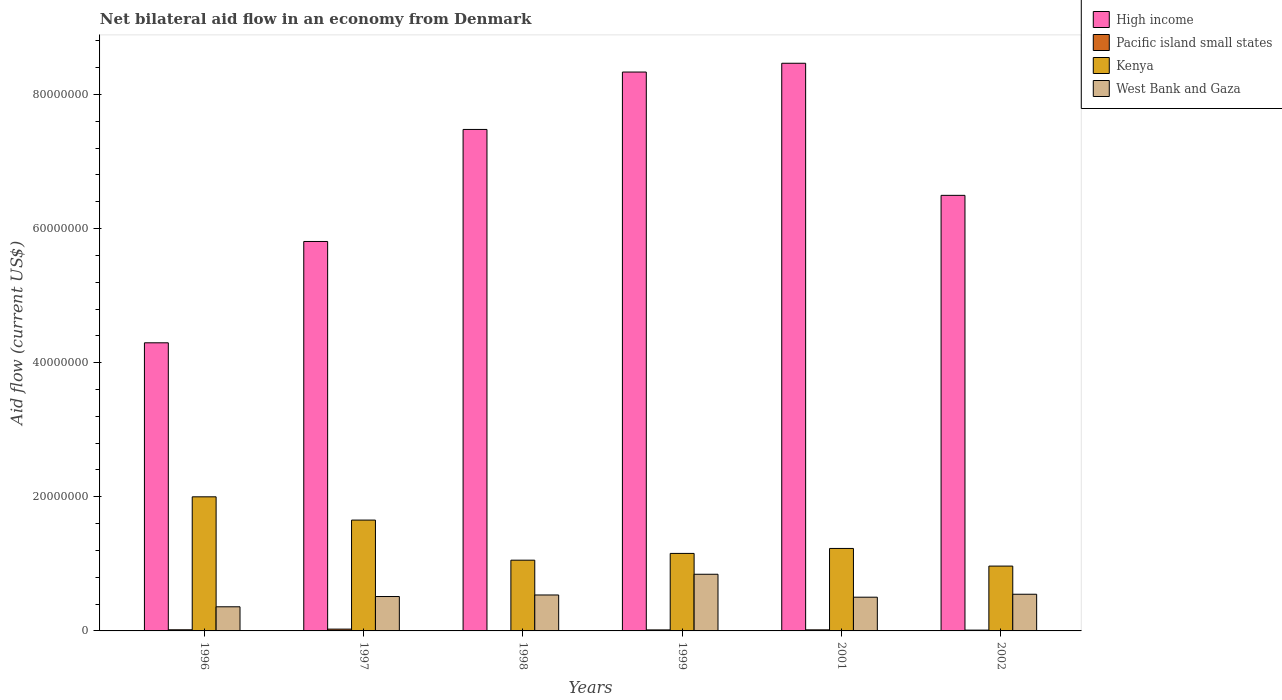Are the number of bars per tick equal to the number of legend labels?
Ensure brevity in your answer.  No. How many bars are there on the 6th tick from the left?
Provide a succinct answer. 4. What is the label of the 3rd group of bars from the left?
Keep it short and to the point. 1998. In how many cases, is the number of bars for a given year not equal to the number of legend labels?
Your answer should be compact. 1. What is the net bilateral aid flow in West Bank and Gaza in 1997?
Offer a terse response. 5.13e+06. Across all years, what is the maximum net bilateral aid flow in High income?
Give a very brief answer. 8.47e+07. In which year was the net bilateral aid flow in West Bank and Gaza maximum?
Offer a very short reply. 1999. What is the total net bilateral aid flow in West Bank and Gaza in the graph?
Offer a terse response. 3.30e+07. What is the difference between the net bilateral aid flow in High income in 1998 and that in 1999?
Give a very brief answer. -8.56e+06. What is the difference between the net bilateral aid flow in Pacific island small states in 1999 and the net bilateral aid flow in West Bank and Gaza in 1996?
Your answer should be very brief. -3.45e+06. What is the average net bilateral aid flow in Kenya per year?
Your answer should be very brief. 1.34e+07. In the year 1996, what is the difference between the net bilateral aid flow in Pacific island small states and net bilateral aid flow in High income?
Your answer should be very brief. -4.28e+07. In how many years, is the net bilateral aid flow in High income greater than 56000000 US$?
Your answer should be very brief. 5. What is the difference between the highest and the second highest net bilateral aid flow in High income?
Your answer should be compact. 1.31e+06. What is the difference between the highest and the lowest net bilateral aid flow in High income?
Give a very brief answer. 4.17e+07. In how many years, is the net bilateral aid flow in High income greater than the average net bilateral aid flow in High income taken over all years?
Provide a succinct answer. 3. Is it the case that in every year, the sum of the net bilateral aid flow in High income and net bilateral aid flow in Kenya is greater than the sum of net bilateral aid flow in Pacific island small states and net bilateral aid flow in West Bank and Gaza?
Offer a very short reply. No. Are the values on the major ticks of Y-axis written in scientific E-notation?
Offer a very short reply. No. Does the graph contain grids?
Provide a short and direct response. No. Where does the legend appear in the graph?
Your answer should be very brief. Top right. What is the title of the graph?
Make the answer very short. Net bilateral aid flow in an economy from Denmark. Does "Mauritania" appear as one of the legend labels in the graph?
Give a very brief answer. No. What is the label or title of the Y-axis?
Your response must be concise. Aid flow (current US$). What is the Aid flow (current US$) of High income in 1996?
Your answer should be compact. 4.30e+07. What is the Aid flow (current US$) of Kenya in 1996?
Provide a succinct answer. 2.00e+07. What is the Aid flow (current US$) in West Bank and Gaza in 1996?
Your response must be concise. 3.60e+06. What is the Aid flow (current US$) in High income in 1997?
Offer a very short reply. 5.81e+07. What is the Aid flow (current US$) of Kenya in 1997?
Your answer should be very brief. 1.65e+07. What is the Aid flow (current US$) in West Bank and Gaza in 1997?
Offer a terse response. 5.13e+06. What is the Aid flow (current US$) of High income in 1998?
Offer a very short reply. 7.48e+07. What is the Aid flow (current US$) in Pacific island small states in 1998?
Your answer should be very brief. 0. What is the Aid flow (current US$) of Kenya in 1998?
Your answer should be compact. 1.06e+07. What is the Aid flow (current US$) in West Bank and Gaza in 1998?
Keep it short and to the point. 5.36e+06. What is the Aid flow (current US$) in High income in 1999?
Provide a succinct answer. 8.34e+07. What is the Aid flow (current US$) of Kenya in 1999?
Give a very brief answer. 1.16e+07. What is the Aid flow (current US$) in West Bank and Gaza in 1999?
Offer a terse response. 8.45e+06. What is the Aid flow (current US$) of High income in 2001?
Provide a short and direct response. 8.47e+07. What is the Aid flow (current US$) in Kenya in 2001?
Keep it short and to the point. 1.23e+07. What is the Aid flow (current US$) of West Bank and Gaza in 2001?
Provide a short and direct response. 5.03e+06. What is the Aid flow (current US$) of High income in 2002?
Ensure brevity in your answer.  6.50e+07. What is the Aid flow (current US$) of Kenya in 2002?
Keep it short and to the point. 9.67e+06. What is the Aid flow (current US$) of West Bank and Gaza in 2002?
Provide a short and direct response. 5.47e+06. Across all years, what is the maximum Aid flow (current US$) of High income?
Ensure brevity in your answer.  8.47e+07. Across all years, what is the maximum Aid flow (current US$) in Pacific island small states?
Ensure brevity in your answer.  2.70e+05. Across all years, what is the maximum Aid flow (current US$) of West Bank and Gaza?
Your answer should be very brief. 8.45e+06. Across all years, what is the minimum Aid flow (current US$) in High income?
Ensure brevity in your answer.  4.30e+07. Across all years, what is the minimum Aid flow (current US$) in Kenya?
Give a very brief answer. 9.67e+06. Across all years, what is the minimum Aid flow (current US$) in West Bank and Gaza?
Provide a succinct answer. 3.60e+06. What is the total Aid flow (current US$) in High income in the graph?
Your answer should be compact. 4.09e+08. What is the total Aid flow (current US$) of Pacific island small states in the graph?
Make the answer very short. 8.70e+05. What is the total Aid flow (current US$) in Kenya in the graph?
Your response must be concise. 8.06e+07. What is the total Aid flow (current US$) in West Bank and Gaza in the graph?
Your response must be concise. 3.30e+07. What is the difference between the Aid flow (current US$) of High income in 1996 and that in 1997?
Offer a terse response. -1.51e+07. What is the difference between the Aid flow (current US$) of Kenya in 1996 and that in 1997?
Offer a very short reply. 3.47e+06. What is the difference between the Aid flow (current US$) of West Bank and Gaza in 1996 and that in 1997?
Give a very brief answer. -1.53e+06. What is the difference between the Aid flow (current US$) of High income in 1996 and that in 1998?
Your response must be concise. -3.18e+07. What is the difference between the Aid flow (current US$) in Kenya in 1996 and that in 1998?
Provide a short and direct response. 9.45e+06. What is the difference between the Aid flow (current US$) of West Bank and Gaza in 1996 and that in 1998?
Your answer should be compact. -1.76e+06. What is the difference between the Aid flow (current US$) in High income in 1996 and that in 1999?
Offer a very short reply. -4.04e+07. What is the difference between the Aid flow (current US$) of Kenya in 1996 and that in 1999?
Keep it short and to the point. 8.44e+06. What is the difference between the Aid flow (current US$) in West Bank and Gaza in 1996 and that in 1999?
Give a very brief answer. -4.85e+06. What is the difference between the Aid flow (current US$) of High income in 1996 and that in 2001?
Your response must be concise. -4.17e+07. What is the difference between the Aid flow (current US$) in Kenya in 1996 and that in 2001?
Make the answer very short. 7.70e+06. What is the difference between the Aid flow (current US$) of West Bank and Gaza in 1996 and that in 2001?
Make the answer very short. -1.43e+06. What is the difference between the Aid flow (current US$) of High income in 1996 and that in 2002?
Provide a succinct answer. -2.20e+07. What is the difference between the Aid flow (current US$) of Kenya in 1996 and that in 2002?
Your response must be concise. 1.03e+07. What is the difference between the Aid flow (current US$) of West Bank and Gaza in 1996 and that in 2002?
Your response must be concise. -1.87e+06. What is the difference between the Aid flow (current US$) in High income in 1997 and that in 1998?
Ensure brevity in your answer.  -1.67e+07. What is the difference between the Aid flow (current US$) in Kenya in 1997 and that in 1998?
Keep it short and to the point. 5.98e+06. What is the difference between the Aid flow (current US$) of West Bank and Gaza in 1997 and that in 1998?
Provide a short and direct response. -2.30e+05. What is the difference between the Aid flow (current US$) in High income in 1997 and that in 1999?
Make the answer very short. -2.53e+07. What is the difference between the Aid flow (current US$) in Kenya in 1997 and that in 1999?
Ensure brevity in your answer.  4.97e+06. What is the difference between the Aid flow (current US$) of West Bank and Gaza in 1997 and that in 1999?
Offer a terse response. -3.32e+06. What is the difference between the Aid flow (current US$) of High income in 1997 and that in 2001?
Your answer should be very brief. -2.66e+07. What is the difference between the Aid flow (current US$) in Kenya in 1997 and that in 2001?
Offer a very short reply. 4.23e+06. What is the difference between the Aid flow (current US$) in High income in 1997 and that in 2002?
Offer a very short reply. -6.88e+06. What is the difference between the Aid flow (current US$) of Pacific island small states in 1997 and that in 2002?
Make the answer very short. 1.50e+05. What is the difference between the Aid flow (current US$) in Kenya in 1997 and that in 2002?
Provide a short and direct response. 6.86e+06. What is the difference between the Aid flow (current US$) of West Bank and Gaza in 1997 and that in 2002?
Offer a very short reply. -3.40e+05. What is the difference between the Aid flow (current US$) in High income in 1998 and that in 1999?
Your response must be concise. -8.56e+06. What is the difference between the Aid flow (current US$) in Kenya in 1998 and that in 1999?
Give a very brief answer. -1.01e+06. What is the difference between the Aid flow (current US$) of West Bank and Gaza in 1998 and that in 1999?
Keep it short and to the point. -3.09e+06. What is the difference between the Aid flow (current US$) in High income in 1998 and that in 2001?
Your response must be concise. -9.87e+06. What is the difference between the Aid flow (current US$) of Kenya in 1998 and that in 2001?
Ensure brevity in your answer.  -1.75e+06. What is the difference between the Aid flow (current US$) of High income in 1998 and that in 2002?
Your response must be concise. 9.83e+06. What is the difference between the Aid flow (current US$) in Kenya in 1998 and that in 2002?
Provide a succinct answer. 8.80e+05. What is the difference between the Aid flow (current US$) in High income in 1999 and that in 2001?
Offer a terse response. -1.31e+06. What is the difference between the Aid flow (current US$) in Pacific island small states in 1999 and that in 2001?
Your answer should be very brief. -10000. What is the difference between the Aid flow (current US$) of Kenya in 1999 and that in 2001?
Your response must be concise. -7.40e+05. What is the difference between the Aid flow (current US$) in West Bank and Gaza in 1999 and that in 2001?
Offer a very short reply. 3.42e+06. What is the difference between the Aid flow (current US$) in High income in 1999 and that in 2002?
Your response must be concise. 1.84e+07. What is the difference between the Aid flow (current US$) in Kenya in 1999 and that in 2002?
Give a very brief answer. 1.89e+06. What is the difference between the Aid flow (current US$) of West Bank and Gaza in 1999 and that in 2002?
Keep it short and to the point. 2.98e+06. What is the difference between the Aid flow (current US$) in High income in 2001 and that in 2002?
Keep it short and to the point. 1.97e+07. What is the difference between the Aid flow (current US$) of Pacific island small states in 2001 and that in 2002?
Ensure brevity in your answer.  4.00e+04. What is the difference between the Aid flow (current US$) of Kenya in 2001 and that in 2002?
Provide a short and direct response. 2.63e+06. What is the difference between the Aid flow (current US$) in West Bank and Gaza in 2001 and that in 2002?
Keep it short and to the point. -4.40e+05. What is the difference between the Aid flow (current US$) in High income in 1996 and the Aid flow (current US$) in Pacific island small states in 1997?
Offer a very short reply. 4.27e+07. What is the difference between the Aid flow (current US$) in High income in 1996 and the Aid flow (current US$) in Kenya in 1997?
Your answer should be compact. 2.64e+07. What is the difference between the Aid flow (current US$) of High income in 1996 and the Aid flow (current US$) of West Bank and Gaza in 1997?
Give a very brief answer. 3.78e+07. What is the difference between the Aid flow (current US$) in Pacific island small states in 1996 and the Aid flow (current US$) in Kenya in 1997?
Make the answer very short. -1.64e+07. What is the difference between the Aid flow (current US$) of Pacific island small states in 1996 and the Aid flow (current US$) of West Bank and Gaza in 1997?
Your answer should be very brief. -4.96e+06. What is the difference between the Aid flow (current US$) in Kenya in 1996 and the Aid flow (current US$) in West Bank and Gaza in 1997?
Your answer should be compact. 1.49e+07. What is the difference between the Aid flow (current US$) in High income in 1996 and the Aid flow (current US$) in Kenya in 1998?
Provide a succinct answer. 3.24e+07. What is the difference between the Aid flow (current US$) of High income in 1996 and the Aid flow (current US$) of West Bank and Gaza in 1998?
Give a very brief answer. 3.76e+07. What is the difference between the Aid flow (current US$) of Pacific island small states in 1996 and the Aid flow (current US$) of Kenya in 1998?
Keep it short and to the point. -1.04e+07. What is the difference between the Aid flow (current US$) of Pacific island small states in 1996 and the Aid flow (current US$) of West Bank and Gaza in 1998?
Ensure brevity in your answer.  -5.19e+06. What is the difference between the Aid flow (current US$) of Kenya in 1996 and the Aid flow (current US$) of West Bank and Gaza in 1998?
Offer a terse response. 1.46e+07. What is the difference between the Aid flow (current US$) of High income in 1996 and the Aid flow (current US$) of Pacific island small states in 1999?
Provide a short and direct response. 4.28e+07. What is the difference between the Aid flow (current US$) in High income in 1996 and the Aid flow (current US$) in Kenya in 1999?
Your answer should be very brief. 3.14e+07. What is the difference between the Aid flow (current US$) in High income in 1996 and the Aid flow (current US$) in West Bank and Gaza in 1999?
Keep it short and to the point. 3.45e+07. What is the difference between the Aid flow (current US$) of Pacific island small states in 1996 and the Aid flow (current US$) of Kenya in 1999?
Offer a very short reply. -1.14e+07. What is the difference between the Aid flow (current US$) in Pacific island small states in 1996 and the Aid flow (current US$) in West Bank and Gaza in 1999?
Give a very brief answer. -8.28e+06. What is the difference between the Aid flow (current US$) of Kenya in 1996 and the Aid flow (current US$) of West Bank and Gaza in 1999?
Provide a succinct answer. 1.16e+07. What is the difference between the Aid flow (current US$) in High income in 1996 and the Aid flow (current US$) in Pacific island small states in 2001?
Offer a very short reply. 4.28e+07. What is the difference between the Aid flow (current US$) of High income in 1996 and the Aid flow (current US$) of Kenya in 2001?
Make the answer very short. 3.07e+07. What is the difference between the Aid flow (current US$) in High income in 1996 and the Aid flow (current US$) in West Bank and Gaza in 2001?
Give a very brief answer. 3.79e+07. What is the difference between the Aid flow (current US$) of Pacific island small states in 1996 and the Aid flow (current US$) of Kenya in 2001?
Keep it short and to the point. -1.21e+07. What is the difference between the Aid flow (current US$) in Pacific island small states in 1996 and the Aid flow (current US$) in West Bank and Gaza in 2001?
Your response must be concise. -4.86e+06. What is the difference between the Aid flow (current US$) of Kenya in 1996 and the Aid flow (current US$) of West Bank and Gaza in 2001?
Provide a short and direct response. 1.50e+07. What is the difference between the Aid flow (current US$) of High income in 1996 and the Aid flow (current US$) of Pacific island small states in 2002?
Ensure brevity in your answer.  4.28e+07. What is the difference between the Aid flow (current US$) in High income in 1996 and the Aid flow (current US$) in Kenya in 2002?
Keep it short and to the point. 3.33e+07. What is the difference between the Aid flow (current US$) in High income in 1996 and the Aid flow (current US$) in West Bank and Gaza in 2002?
Give a very brief answer. 3.75e+07. What is the difference between the Aid flow (current US$) of Pacific island small states in 1996 and the Aid flow (current US$) of Kenya in 2002?
Ensure brevity in your answer.  -9.50e+06. What is the difference between the Aid flow (current US$) of Pacific island small states in 1996 and the Aid flow (current US$) of West Bank and Gaza in 2002?
Your answer should be compact. -5.30e+06. What is the difference between the Aid flow (current US$) in Kenya in 1996 and the Aid flow (current US$) in West Bank and Gaza in 2002?
Provide a short and direct response. 1.45e+07. What is the difference between the Aid flow (current US$) of High income in 1997 and the Aid flow (current US$) of Kenya in 1998?
Provide a short and direct response. 4.75e+07. What is the difference between the Aid flow (current US$) in High income in 1997 and the Aid flow (current US$) in West Bank and Gaza in 1998?
Provide a succinct answer. 5.27e+07. What is the difference between the Aid flow (current US$) in Pacific island small states in 1997 and the Aid flow (current US$) in Kenya in 1998?
Your response must be concise. -1.03e+07. What is the difference between the Aid flow (current US$) of Pacific island small states in 1997 and the Aid flow (current US$) of West Bank and Gaza in 1998?
Offer a very short reply. -5.09e+06. What is the difference between the Aid flow (current US$) of Kenya in 1997 and the Aid flow (current US$) of West Bank and Gaza in 1998?
Your answer should be very brief. 1.12e+07. What is the difference between the Aid flow (current US$) in High income in 1997 and the Aid flow (current US$) in Pacific island small states in 1999?
Make the answer very short. 5.79e+07. What is the difference between the Aid flow (current US$) in High income in 1997 and the Aid flow (current US$) in Kenya in 1999?
Your response must be concise. 4.65e+07. What is the difference between the Aid flow (current US$) in High income in 1997 and the Aid flow (current US$) in West Bank and Gaza in 1999?
Give a very brief answer. 4.96e+07. What is the difference between the Aid flow (current US$) of Pacific island small states in 1997 and the Aid flow (current US$) of Kenya in 1999?
Your answer should be very brief. -1.13e+07. What is the difference between the Aid flow (current US$) in Pacific island small states in 1997 and the Aid flow (current US$) in West Bank and Gaza in 1999?
Give a very brief answer. -8.18e+06. What is the difference between the Aid flow (current US$) of Kenya in 1997 and the Aid flow (current US$) of West Bank and Gaza in 1999?
Give a very brief answer. 8.08e+06. What is the difference between the Aid flow (current US$) in High income in 1997 and the Aid flow (current US$) in Pacific island small states in 2001?
Your answer should be very brief. 5.79e+07. What is the difference between the Aid flow (current US$) of High income in 1997 and the Aid flow (current US$) of Kenya in 2001?
Make the answer very short. 4.58e+07. What is the difference between the Aid flow (current US$) of High income in 1997 and the Aid flow (current US$) of West Bank and Gaza in 2001?
Give a very brief answer. 5.30e+07. What is the difference between the Aid flow (current US$) in Pacific island small states in 1997 and the Aid flow (current US$) in Kenya in 2001?
Your answer should be very brief. -1.20e+07. What is the difference between the Aid flow (current US$) of Pacific island small states in 1997 and the Aid flow (current US$) of West Bank and Gaza in 2001?
Your answer should be very brief. -4.76e+06. What is the difference between the Aid flow (current US$) of Kenya in 1997 and the Aid flow (current US$) of West Bank and Gaza in 2001?
Provide a short and direct response. 1.15e+07. What is the difference between the Aid flow (current US$) in High income in 1997 and the Aid flow (current US$) in Pacific island small states in 2002?
Ensure brevity in your answer.  5.80e+07. What is the difference between the Aid flow (current US$) of High income in 1997 and the Aid flow (current US$) of Kenya in 2002?
Give a very brief answer. 4.84e+07. What is the difference between the Aid flow (current US$) of High income in 1997 and the Aid flow (current US$) of West Bank and Gaza in 2002?
Keep it short and to the point. 5.26e+07. What is the difference between the Aid flow (current US$) of Pacific island small states in 1997 and the Aid flow (current US$) of Kenya in 2002?
Your answer should be compact. -9.40e+06. What is the difference between the Aid flow (current US$) of Pacific island small states in 1997 and the Aid flow (current US$) of West Bank and Gaza in 2002?
Your answer should be very brief. -5.20e+06. What is the difference between the Aid flow (current US$) in Kenya in 1997 and the Aid flow (current US$) in West Bank and Gaza in 2002?
Your response must be concise. 1.11e+07. What is the difference between the Aid flow (current US$) in High income in 1998 and the Aid flow (current US$) in Pacific island small states in 1999?
Make the answer very short. 7.46e+07. What is the difference between the Aid flow (current US$) in High income in 1998 and the Aid flow (current US$) in Kenya in 1999?
Provide a succinct answer. 6.32e+07. What is the difference between the Aid flow (current US$) of High income in 1998 and the Aid flow (current US$) of West Bank and Gaza in 1999?
Ensure brevity in your answer.  6.63e+07. What is the difference between the Aid flow (current US$) in Kenya in 1998 and the Aid flow (current US$) in West Bank and Gaza in 1999?
Provide a short and direct response. 2.10e+06. What is the difference between the Aid flow (current US$) in High income in 1998 and the Aid flow (current US$) in Pacific island small states in 2001?
Offer a terse response. 7.46e+07. What is the difference between the Aid flow (current US$) of High income in 1998 and the Aid flow (current US$) of Kenya in 2001?
Provide a succinct answer. 6.25e+07. What is the difference between the Aid flow (current US$) in High income in 1998 and the Aid flow (current US$) in West Bank and Gaza in 2001?
Offer a very short reply. 6.98e+07. What is the difference between the Aid flow (current US$) in Kenya in 1998 and the Aid flow (current US$) in West Bank and Gaza in 2001?
Your answer should be compact. 5.52e+06. What is the difference between the Aid flow (current US$) of High income in 1998 and the Aid flow (current US$) of Pacific island small states in 2002?
Make the answer very short. 7.47e+07. What is the difference between the Aid flow (current US$) in High income in 1998 and the Aid flow (current US$) in Kenya in 2002?
Your answer should be very brief. 6.51e+07. What is the difference between the Aid flow (current US$) of High income in 1998 and the Aid flow (current US$) of West Bank and Gaza in 2002?
Provide a succinct answer. 6.93e+07. What is the difference between the Aid flow (current US$) of Kenya in 1998 and the Aid flow (current US$) of West Bank and Gaza in 2002?
Provide a succinct answer. 5.08e+06. What is the difference between the Aid flow (current US$) of High income in 1999 and the Aid flow (current US$) of Pacific island small states in 2001?
Offer a terse response. 8.32e+07. What is the difference between the Aid flow (current US$) of High income in 1999 and the Aid flow (current US$) of Kenya in 2001?
Offer a terse response. 7.10e+07. What is the difference between the Aid flow (current US$) in High income in 1999 and the Aid flow (current US$) in West Bank and Gaza in 2001?
Provide a short and direct response. 7.83e+07. What is the difference between the Aid flow (current US$) in Pacific island small states in 1999 and the Aid flow (current US$) in Kenya in 2001?
Your answer should be very brief. -1.22e+07. What is the difference between the Aid flow (current US$) of Pacific island small states in 1999 and the Aid flow (current US$) of West Bank and Gaza in 2001?
Keep it short and to the point. -4.88e+06. What is the difference between the Aid flow (current US$) in Kenya in 1999 and the Aid flow (current US$) in West Bank and Gaza in 2001?
Offer a terse response. 6.53e+06. What is the difference between the Aid flow (current US$) of High income in 1999 and the Aid flow (current US$) of Pacific island small states in 2002?
Provide a succinct answer. 8.32e+07. What is the difference between the Aid flow (current US$) of High income in 1999 and the Aid flow (current US$) of Kenya in 2002?
Make the answer very short. 7.37e+07. What is the difference between the Aid flow (current US$) of High income in 1999 and the Aid flow (current US$) of West Bank and Gaza in 2002?
Your response must be concise. 7.79e+07. What is the difference between the Aid flow (current US$) in Pacific island small states in 1999 and the Aid flow (current US$) in Kenya in 2002?
Provide a short and direct response. -9.52e+06. What is the difference between the Aid flow (current US$) in Pacific island small states in 1999 and the Aid flow (current US$) in West Bank and Gaza in 2002?
Your answer should be compact. -5.32e+06. What is the difference between the Aid flow (current US$) in Kenya in 1999 and the Aid flow (current US$) in West Bank and Gaza in 2002?
Provide a succinct answer. 6.09e+06. What is the difference between the Aid flow (current US$) in High income in 2001 and the Aid flow (current US$) in Pacific island small states in 2002?
Ensure brevity in your answer.  8.45e+07. What is the difference between the Aid flow (current US$) in High income in 2001 and the Aid flow (current US$) in Kenya in 2002?
Provide a short and direct response. 7.50e+07. What is the difference between the Aid flow (current US$) in High income in 2001 and the Aid flow (current US$) in West Bank and Gaza in 2002?
Give a very brief answer. 7.92e+07. What is the difference between the Aid flow (current US$) of Pacific island small states in 2001 and the Aid flow (current US$) of Kenya in 2002?
Provide a short and direct response. -9.51e+06. What is the difference between the Aid flow (current US$) of Pacific island small states in 2001 and the Aid flow (current US$) of West Bank and Gaza in 2002?
Provide a succinct answer. -5.31e+06. What is the difference between the Aid flow (current US$) in Kenya in 2001 and the Aid flow (current US$) in West Bank and Gaza in 2002?
Offer a terse response. 6.83e+06. What is the average Aid flow (current US$) in High income per year?
Your response must be concise. 6.81e+07. What is the average Aid flow (current US$) in Pacific island small states per year?
Give a very brief answer. 1.45e+05. What is the average Aid flow (current US$) in Kenya per year?
Offer a very short reply. 1.34e+07. What is the average Aid flow (current US$) of West Bank and Gaza per year?
Your answer should be very brief. 5.51e+06. In the year 1996, what is the difference between the Aid flow (current US$) of High income and Aid flow (current US$) of Pacific island small states?
Give a very brief answer. 4.28e+07. In the year 1996, what is the difference between the Aid flow (current US$) in High income and Aid flow (current US$) in Kenya?
Give a very brief answer. 2.30e+07. In the year 1996, what is the difference between the Aid flow (current US$) in High income and Aid flow (current US$) in West Bank and Gaza?
Give a very brief answer. 3.94e+07. In the year 1996, what is the difference between the Aid flow (current US$) of Pacific island small states and Aid flow (current US$) of Kenya?
Ensure brevity in your answer.  -1.98e+07. In the year 1996, what is the difference between the Aid flow (current US$) in Pacific island small states and Aid flow (current US$) in West Bank and Gaza?
Offer a terse response. -3.43e+06. In the year 1996, what is the difference between the Aid flow (current US$) in Kenya and Aid flow (current US$) in West Bank and Gaza?
Your answer should be very brief. 1.64e+07. In the year 1997, what is the difference between the Aid flow (current US$) of High income and Aid flow (current US$) of Pacific island small states?
Provide a short and direct response. 5.78e+07. In the year 1997, what is the difference between the Aid flow (current US$) in High income and Aid flow (current US$) in Kenya?
Ensure brevity in your answer.  4.16e+07. In the year 1997, what is the difference between the Aid flow (current US$) of High income and Aid flow (current US$) of West Bank and Gaza?
Provide a short and direct response. 5.30e+07. In the year 1997, what is the difference between the Aid flow (current US$) in Pacific island small states and Aid flow (current US$) in Kenya?
Your answer should be compact. -1.63e+07. In the year 1997, what is the difference between the Aid flow (current US$) of Pacific island small states and Aid flow (current US$) of West Bank and Gaza?
Provide a succinct answer. -4.86e+06. In the year 1997, what is the difference between the Aid flow (current US$) of Kenya and Aid flow (current US$) of West Bank and Gaza?
Give a very brief answer. 1.14e+07. In the year 1998, what is the difference between the Aid flow (current US$) in High income and Aid flow (current US$) in Kenya?
Make the answer very short. 6.42e+07. In the year 1998, what is the difference between the Aid flow (current US$) in High income and Aid flow (current US$) in West Bank and Gaza?
Keep it short and to the point. 6.94e+07. In the year 1998, what is the difference between the Aid flow (current US$) in Kenya and Aid flow (current US$) in West Bank and Gaza?
Your response must be concise. 5.19e+06. In the year 1999, what is the difference between the Aid flow (current US$) in High income and Aid flow (current US$) in Pacific island small states?
Offer a terse response. 8.32e+07. In the year 1999, what is the difference between the Aid flow (current US$) in High income and Aid flow (current US$) in Kenya?
Give a very brief answer. 7.18e+07. In the year 1999, what is the difference between the Aid flow (current US$) in High income and Aid flow (current US$) in West Bank and Gaza?
Provide a succinct answer. 7.49e+07. In the year 1999, what is the difference between the Aid flow (current US$) in Pacific island small states and Aid flow (current US$) in Kenya?
Offer a very short reply. -1.14e+07. In the year 1999, what is the difference between the Aid flow (current US$) in Pacific island small states and Aid flow (current US$) in West Bank and Gaza?
Make the answer very short. -8.30e+06. In the year 1999, what is the difference between the Aid flow (current US$) in Kenya and Aid flow (current US$) in West Bank and Gaza?
Provide a succinct answer. 3.11e+06. In the year 2001, what is the difference between the Aid flow (current US$) of High income and Aid flow (current US$) of Pacific island small states?
Provide a short and direct response. 8.45e+07. In the year 2001, what is the difference between the Aid flow (current US$) in High income and Aid flow (current US$) in Kenya?
Keep it short and to the point. 7.24e+07. In the year 2001, what is the difference between the Aid flow (current US$) in High income and Aid flow (current US$) in West Bank and Gaza?
Your response must be concise. 7.96e+07. In the year 2001, what is the difference between the Aid flow (current US$) in Pacific island small states and Aid flow (current US$) in Kenya?
Offer a terse response. -1.21e+07. In the year 2001, what is the difference between the Aid flow (current US$) of Pacific island small states and Aid flow (current US$) of West Bank and Gaza?
Your response must be concise. -4.87e+06. In the year 2001, what is the difference between the Aid flow (current US$) in Kenya and Aid flow (current US$) in West Bank and Gaza?
Ensure brevity in your answer.  7.27e+06. In the year 2002, what is the difference between the Aid flow (current US$) of High income and Aid flow (current US$) of Pacific island small states?
Your response must be concise. 6.48e+07. In the year 2002, what is the difference between the Aid flow (current US$) of High income and Aid flow (current US$) of Kenya?
Give a very brief answer. 5.53e+07. In the year 2002, what is the difference between the Aid flow (current US$) of High income and Aid flow (current US$) of West Bank and Gaza?
Your answer should be very brief. 5.95e+07. In the year 2002, what is the difference between the Aid flow (current US$) of Pacific island small states and Aid flow (current US$) of Kenya?
Give a very brief answer. -9.55e+06. In the year 2002, what is the difference between the Aid flow (current US$) in Pacific island small states and Aid flow (current US$) in West Bank and Gaza?
Your answer should be very brief. -5.35e+06. In the year 2002, what is the difference between the Aid flow (current US$) in Kenya and Aid flow (current US$) in West Bank and Gaza?
Offer a very short reply. 4.20e+06. What is the ratio of the Aid flow (current US$) in High income in 1996 to that in 1997?
Provide a short and direct response. 0.74. What is the ratio of the Aid flow (current US$) of Pacific island small states in 1996 to that in 1997?
Provide a succinct answer. 0.63. What is the ratio of the Aid flow (current US$) in Kenya in 1996 to that in 1997?
Make the answer very short. 1.21. What is the ratio of the Aid flow (current US$) of West Bank and Gaza in 1996 to that in 1997?
Your answer should be very brief. 0.7. What is the ratio of the Aid flow (current US$) of High income in 1996 to that in 1998?
Offer a terse response. 0.57. What is the ratio of the Aid flow (current US$) in Kenya in 1996 to that in 1998?
Your answer should be compact. 1.9. What is the ratio of the Aid flow (current US$) of West Bank and Gaza in 1996 to that in 1998?
Keep it short and to the point. 0.67. What is the ratio of the Aid flow (current US$) in High income in 1996 to that in 1999?
Your answer should be compact. 0.52. What is the ratio of the Aid flow (current US$) of Pacific island small states in 1996 to that in 1999?
Keep it short and to the point. 1.13. What is the ratio of the Aid flow (current US$) in Kenya in 1996 to that in 1999?
Offer a very short reply. 1.73. What is the ratio of the Aid flow (current US$) in West Bank and Gaza in 1996 to that in 1999?
Give a very brief answer. 0.43. What is the ratio of the Aid flow (current US$) of High income in 1996 to that in 2001?
Offer a very short reply. 0.51. What is the ratio of the Aid flow (current US$) of Pacific island small states in 1996 to that in 2001?
Your answer should be compact. 1.06. What is the ratio of the Aid flow (current US$) in Kenya in 1996 to that in 2001?
Keep it short and to the point. 1.63. What is the ratio of the Aid flow (current US$) in West Bank and Gaza in 1996 to that in 2001?
Give a very brief answer. 0.72. What is the ratio of the Aid flow (current US$) in High income in 1996 to that in 2002?
Your answer should be very brief. 0.66. What is the ratio of the Aid flow (current US$) of Pacific island small states in 1996 to that in 2002?
Give a very brief answer. 1.42. What is the ratio of the Aid flow (current US$) in Kenya in 1996 to that in 2002?
Provide a short and direct response. 2.07. What is the ratio of the Aid flow (current US$) of West Bank and Gaza in 1996 to that in 2002?
Offer a terse response. 0.66. What is the ratio of the Aid flow (current US$) of High income in 1997 to that in 1998?
Your answer should be compact. 0.78. What is the ratio of the Aid flow (current US$) in Kenya in 1997 to that in 1998?
Ensure brevity in your answer.  1.57. What is the ratio of the Aid flow (current US$) in West Bank and Gaza in 1997 to that in 1998?
Offer a terse response. 0.96. What is the ratio of the Aid flow (current US$) of High income in 1997 to that in 1999?
Make the answer very short. 0.7. What is the ratio of the Aid flow (current US$) of Kenya in 1997 to that in 1999?
Offer a terse response. 1.43. What is the ratio of the Aid flow (current US$) in West Bank and Gaza in 1997 to that in 1999?
Keep it short and to the point. 0.61. What is the ratio of the Aid flow (current US$) in High income in 1997 to that in 2001?
Keep it short and to the point. 0.69. What is the ratio of the Aid flow (current US$) in Pacific island small states in 1997 to that in 2001?
Provide a short and direct response. 1.69. What is the ratio of the Aid flow (current US$) of Kenya in 1997 to that in 2001?
Provide a succinct answer. 1.34. What is the ratio of the Aid flow (current US$) of West Bank and Gaza in 1997 to that in 2001?
Your answer should be compact. 1.02. What is the ratio of the Aid flow (current US$) of High income in 1997 to that in 2002?
Offer a terse response. 0.89. What is the ratio of the Aid flow (current US$) in Pacific island small states in 1997 to that in 2002?
Make the answer very short. 2.25. What is the ratio of the Aid flow (current US$) of Kenya in 1997 to that in 2002?
Ensure brevity in your answer.  1.71. What is the ratio of the Aid flow (current US$) of West Bank and Gaza in 1997 to that in 2002?
Ensure brevity in your answer.  0.94. What is the ratio of the Aid flow (current US$) in High income in 1998 to that in 1999?
Your answer should be very brief. 0.9. What is the ratio of the Aid flow (current US$) in Kenya in 1998 to that in 1999?
Give a very brief answer. 0.91. What is the ratio of the Aid flow (current US$) in West Bank and Gaza in 1998 to that in 1999?
Make the answer very short. 0.63. What is the ratio of the Aid flow (current US$) in High income in 1998 to that in 2001?
Provide a succinct answer. 0.88. What is the ratio of the Aid flow (current US$) in Kenya in 1998 to that in 2001?
Make the answer very short. 0.86. What is the ratio of the Aid flow (current US$) of West Bank and Gaza in 1998 to that in 2001?
Give a very brief answer. 1.07. What is the ratio of the Aid flow (current US$) in High income in 1998 to that in 2002?
Your answer should be compact. 1.15. What is the ratio of the Aid flow (current US$) in Kenya in 1998 to that in 2002?
Your answer should be compact. 1.09. What is the ratio of the Aid flow (current US$) in West Bank and Gaza in 1998 to that in 2002?
Offer a terse response. 0.98. What is the ratio of the Aid flow (current US$) of High income in 1999 to that in 2001?
Offer a terse response. 0.98. What is the ratio of the Aid flow (current US$) in Pacific island small states in 1999 to that in 2001?
Offer a terse response. 0.94. What is the ratio of the Aid flow (current US$) of Kenya in 1999 to that in 2001?
Keep it short and to the point. 0.94. What is the ratio of the Aid flow (current US$) of West Bank and Gaza in 1999 to that in 2001?
Provide a succinct answer. 1.68. What is the ratio of the Aid flow (current US$) in High income in 1999 to that in 2002?
Provide a succinct answer. 1.28. What is the ratio of the Aid flow (current US$) of Pacific island small states in 1999 to that in 2002?
Provide a short and direct response. 1.25. What is the ratio of the Aid flow (current US$) of Kenya in 1999 to that in 2002?
Offer a terse response. 1.2. What is the ratio of the Aid flow (current US$) in West Bank and Gaza in 1999 to that in 2002?
Offer a terse response. 1.54. What is the ratio of the Aid flow (current US$) of High income in 2001 to that in 2002?
Offer a terse response. 1.3. What is the ratio of the Aid flow (current US$) in Pacific island small states in 2001 to that in 2002?
Provide a short and direct response. 1.33. What is the ratio of the Aid flow (current US$) in Kenya in 2001 to that in 2002?
Keep it short and to the point. 1.27. What is the ratio of the Aid flow (current US$) of West Bank and Gaza in 2001 to that in 2002?
Make the answer very short. 0.92. What is the difference between the highest and the second highest Aid flow (current US$) of High income?
Ensure brevity in your answer.  1.31e+06. What is the difference between the highest and the second highest Aid flow (current US$) of Pacific island small states?
Provide a short and direct response. 1.00e+05. What is the difference between the highest and the second highest Aid flow (current US$) of Kenya?
Keep it short and to the point. 3.47e+06. What is the difference between the highest and the second highest Aid flow (current US$) of West Bank and Gaza?
Provide a short and direct response. 2.98e+06. What is the difference between the highest and the lowest Aid flow (current US$) in High income?
Your answer should be compact. 4.17e+07. What is the difference between the highest and the lowest Aid flow (current US$) in Kenya?
Give a very brief answer. 1.03e+07. What is the difference between the highest and the lowest Aid flow (current US$) in West Bank and Gaza?
Offer a very short reply. 4.85e+06. 